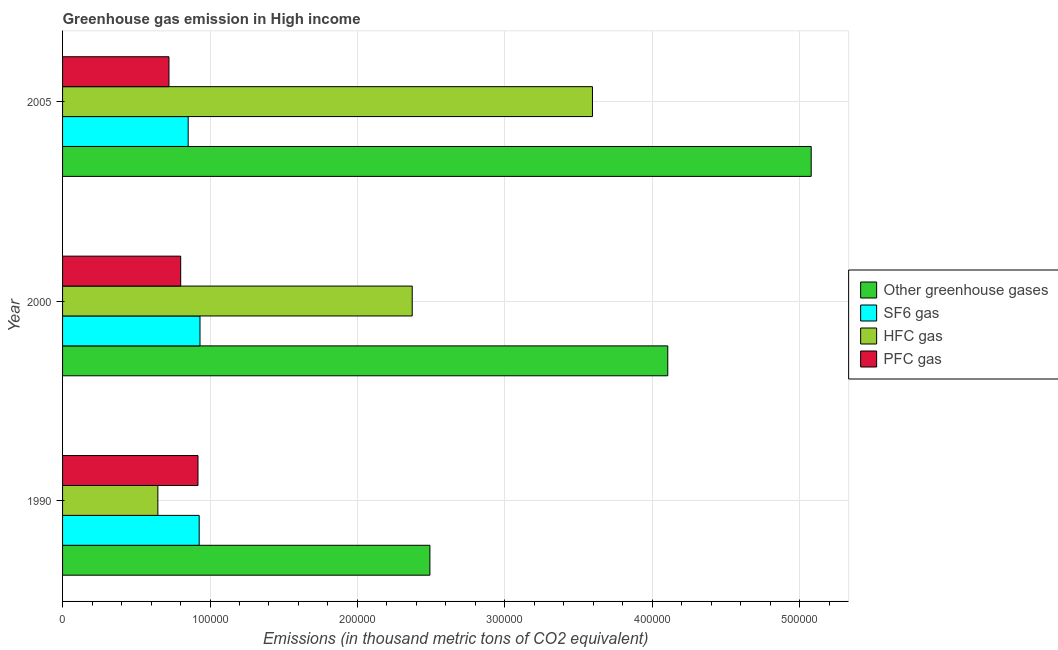How many groups of bars are there?
Keep it short and to the point. 3. How many bars are there on the 2nd tick from the top?
Keep it short and to the point. 4. How many bars are there on the 3rd tick from the bottom?
Provide a succinct answer. 4. What is the label of the 2nd group of bars from the top?
Your response must be concise. 2000. What is the emission of sf6 gas in 2000?
Offer a terse response. 9.32e+04. Across all years, what is the maximum emission of hfc gas?
Provide a short and direct response. 3.59e+05. Across all years, what is the minimum emission of hfc gas?
Give a very brief answer. 6.46e+04. In which year was the emission of hfc gas minimum?
Make the answer very short. 1990. What is the total emission of greenhouse gases in the graph?
Your answer should be very brief. 1.17e+06. What is the difference between the emission of greenhouse gases in 1990 and that in 2005?
Your response must be concise. -2.59e+05. What is the difference between the emission of sf6 gas in 1990 and the emission of greenhouse gases in 2005?
Keep it short and to the point. -4.15e+05. What is the average emission of sf6 gas per year?
Ensure brevity in your answer.  9.04e+04. In the year 1990, what is the difference between the emission of sf6 gas and emission of hfc gas?
Keep it short and to the point. 2.80e+04. What is the ratio of the emission of pfc gas in 1990 to that in 2000?
Your response must be concise. 1.15. Is the difference between the emission of greenhouse gases in 1990 and 2005 greater than the difference between the emission of pfc gas in 1990 and 2005?
Offer a terse response. No. What is the difference between the highest and the second highest emission of pfc gas?
Offer a terse response. 1.17e+04. What is the difference between the highest and the lowest emission of greenhouse gases?
Make the answer very short. 2.59e+05. In how many years, is the emission of pfc gas greater than the average emission of pfc gas taken over all years?
Your answer should be compact. 1. Is the sum of the emission of greenhouse gases in 2000 and 2005 greater than the maximum emission of sf6 gas across all years?
Keep it short and to the point. Yes. Is it the case that in every year, the sum of the emission of sf6 gas and emission of hfc gas is greater than the sum of emission of greenhouse gases and emission of pfc gas?
Keep it short and to the point. No. What does the 2nd bar from the top in 1990 represents?
Give a very brief answer. HFC gas. What does the 2nd bar from the bottom in 2000 represents?
Provide a succinct answer. SF6 gas. How many bars are there?
Offer a very short reply. 12. How many years are there in the graph?
Provide a short and direct response. 3. What is the difference between two consecutive major ticks on the X-axis?
Your answer should be compact. 1.00e+05. Are the values on the major ticks of X-axis written in scientific E-notation?
Ensure brevity in your answer.  No. Does the graph contain any zero values?
Provide a short and direct response. No. What is the title of the graph?
Your response must be concise. Greenhouse gas emission in High income. Does "Secondary general education" appear as one of the legend labels in the graph?
Provide a succinct answer. No. What is the label or title of the X-axis?
Offer a very short reply. Emissions (in thousand metric tons of CO2 equivalent). What is the label or title of the Y-axis?
Provide a short and direct response. Year. What is the Emissions (in thousand metric tons of CO2 equivalent) of Other greenhouse gases in 1990?
Make the answer very short. 2.49e+05. What is the Emissions (in thousand metric tons of CO2 equivalent) of SF6 gas in 1990?
Offer a very short reply. 9.27e+04. What is the Emissions (in thousand metric tons of CO2 equivalent) in HFC gas in 1990?
Your response must be concise. 6.46e+04. What is the Emissions (in thousand metric tons of CO2 equivalent) in PFC gas in 1990?
Keep it short and to the point. 9.19e+04. What is the Emissions (in thousand metric tons of CO2 equivalent) of Other greenhouse gases in 2000?
Provide a short and direct response. 4.10e+05. What is the Emissions (in thousand metric tons of CO2 equivalent) of SF6 gas in 2000?
Offer a terse response. 9.32e+04. What is the Emissions (in thousand metric tons of CO2 equivalent) in HFC gas in 2000?
Make the answer very short. 2.37e+05. What is the Emissions (in thousand metric tons of CO2 equivalent) of PFC gas in 2000?
Ensure brevity in your answer.  8.01e+04. What is the Emissions (in thousand metric tons of CO2 equivalent) of Other greenhouse gases in 2005?
Your response must be concise. 5.08e+05. What is the Emissions (in thousand metric tons of CO2 equivalent) of SF6 gas in 2005?
Offer a very short reply. 8.52e+04. What is the Emissions (in thousand metric tons of CO2 equivalent) of HFC gas in 2005?
Offer a very short reply. 3.59e+05. What is the Emissions (in thousand metric tons of CO2 equivalent) in PFC gas in 2005?
Give a very brief answer. 7.22e+04. Across all years, what is the maximum Emissions (in thousand metric tons of CO2 equivalent) of Other greenhouse gases?
Your answer should be compact. 5.08e+05. Across all years, what is the maximum Emissions (in thousand metric tons of CO2 equivalent) in SF6 gas?
Make the answer very short. 9.32e+04. Across all years, what is the maximum Emissions (in thousand metric tons of CO2 equivalent) in HFC gas?
Offer a very short reply. 3.59e+05. Across all years, what is the maximum Emissions (in thousand metric tons of CO2 equivalent) of PFC gas?
Offer a very short reply. 9.19e+04. Across all years, what is the minimum Emissions (in thousand metric tons of CO2 equivalent) of Other greenhouse gases?
Your answer should be compact. 2.49e+05. Across all years, what is the minimum Emissions (in thousand metric tons of CO2 equivalent) of SF6 gas?
Your answer should be compact. 8.52e+04. Across all years, what is the minimum Emissions (in thousand metric tons of CO2 equivalent) in HFC gas?
Offer a terse response. 6.46e+04. Across all years, what is the minimum Emissions (in thousand metric tons of CO2 equivalent) in PFC gas?
Your answer should be compact. 7.22e+04. What is the total Emissions (in thousand metric tons of CO2 equivalent) in Other greenhouse gases in the graph?
Your answer should be very brief. 1.17e+06. What is the total Emissions (in thousand metric tons of CO2 equivalent) in SF6 gas in the graph?
Provide a short and direct response. 2.71e+05. What is the total Emissions (in thousand metric tons of CO2 equivalent) in HFC gas in the graph?
Provide a short and direct response. 6.61e+05. What is the total Emissions (in thousand metric tons of CO2 equivalent) of PFC gas in the graph?
Your answer should be compact. 2.44e+05. What is the difference between the Emissions (in thousand metric tons of CO2 equivalent) in Other greenhouse gases in 1990 and that in 2000?
Provide a short and direct response. -1.61e+05. What is the difference between the Emissions (in thousand metric tons of CO2 equivalent) in SF6 gas in 1990 and that in 2000?
Keep it short and to the point. -551.2. What is the difference between the Emissions (in thousand metric tons of CO2 equivalent) in HFC gas in 1990 and that in 2000?
Offer a terse response. -1.73e+05. What is the difference between the Emissions (in thousand metric tons of CO2 equivalent) of PFC gas in 1990 and that in 2000?
Offer a terse response. 1.17e+04. What is the difference between the Emissions (in thousand metric tons of CO2 equivalent) of Other greenhouse gases in 1990 and that in 2005?
Provide a short and direct response. -2.59e+05. What is the difference between the Emissions (in thousand metric tons of CO2 equivalent) in SF6 gas in 1990 and that in 2005?
Give a very brief answer. 7470.39. What is the difference between the Emissions (in thousand metric tons of CO2 equivalent) of HFC gas in 1990 and that in 2005?
Your response must be concise. -2.95e+05. What is the difference between the Emissions (in thousand metric tons of CO2 equivalent) in PFC gas in 1990 and that in 2005?
Ensure brevity in your answer.  1.97e+04. What is the difference between the Emissions (in thousand metric tons of CO2 equivalent) of Other greenhouse gases in 2000 and that in 2005?
Your answer should be compact. -9.73e+04. What is the difference between the Emissions (in thousand metric tons of CO2 equivalent) in SF6 gas in 2000 and that in 2005?
Offer a terse response. 8021.59. What is the difference between the Emissions (in thousand metric tons of CO2 equivalent) of HFC gas in 2000 and that in 2005?
Provide a succinct answer. -1.22e+05. What is the difference between the Emissions (in thousand metric tons of CO2 equivalent) of PFC gas in 2000 and that in 2005?
Offer a very short reply. 7954.84. What is the difference between the Emissions (in thousand metric tons of CO2 equivalent) in Other greenhouse gases in 1990 and the Emissions (in thousand metric tons of CO2 equivalent) in SF6 gas in 2000?
Ensure brevity in your answer.  1.56e+05. What is the difference between the Emissions (in thousand metric tons of CO2 equivalent) of Other greenhouse gases in 1990 and the Emissions (in thousand metric tons of CO2 equivalent) of HFC gas in 2000?
Provide a succinct answer. 1.20e+04. What is the difference between the Emissions (in thousand metric tons of CO2 equivalent) of Other greenhouse gases in 1990 and the Emissions (in thousand metric tons of CO2 equivalent) of PFC gas in 2000?
Keep it short and to the point. 1.69e+05. What is the difference between the Emissions (in thousand metric tons of CO2 equivalent) in SF6 gas in 1990 and the Emissions (in thousand metric tons of CO2 equivalent) in HFC gas in 2000?
Offer a terse response. -1.44e+05. What is the difference between the Emissions (in thousand metric tons of CO2 equivalent) in SF6 gas in 1990 and the Emissions (in thousand metric tons of CO2 equivalent) in PFC gas in 2000?
Offer a very short reply. 1.25e+04. What is the difference between the Emissions (in thousand metric tons of CO2 equivalent) of HFC gas in 1990 and the Emissions (in thousand metric tons of CO2 equivalent) of PFC gas in 2000?
Ensure brevity in your answer.  -1.55e+04. What is the difference between the Emissions (in thousand metric tons of CO2 equivalent) of Other greenhouse gases in 1990 and the Emissions (in thousand metric tons of CO2 equivalent) of SF6 gas in 2005?
Offer a terse response. 1.64e+05. What is the difference between the Emissions (in thousand metric tons of CO2 equivalent) of Other greenhouse gases in 1990 and the Emissions (in thousand metric tons of CO2 equivalent) of HFC gas in 2005?
Your response must be concise. -1.10e+05. What is the difference between the Emissions (in thousand metric tons of CO2 equivalent) of Other greenhouse gases in 1990 and the Emissions (in thousand metric tons of CO2 equivalent) of PFC gas in 2005?
Provide a short and direct response. 1.77e+05. What is the difference between the Emissions (in thousand metric tons of CO2 equivalent) of SF6 gas in 1990 and the Emissions (in thousand metric tons of CO2 equivalent) of HFC gas in 2005?
Your response must be concise. -2.67e+05. What is the difference between the Emissions (in thousand metric tons of CO2 equivalent) in SF6 gas in 1990 and the Emissions (in thousand metric tons of CO2 equivalent) in PFC gas in 2005?
Offer a very short reply. 2.05e+04. What is the difference between the Emissions (in thousand metric tons of CO2 equivalent) of HFC gas in 1990 and the Emissions (in thousand metric tons of CO2 equivalent) of PFC gas in 2005?
Provide a succinct answer. -7533.46. What is the difference between the Emissions (in thousand metric tons of CO2 equivalent) of Other greenhouse gases in 2000 and the Emissions (in thousand metric tons of CO2 equivalent) of SF6 gas in 2005?
Make the answer very short. 3.25e+05. What is the difference between the Emissions (in thousand metric tons of CO2 equivalent) in Other greenhouse gases in 2000 and the Emissions (in thousand metric tons of CO2 equivalent) in HFC gas in 2005?
Provide a short and direct response. 5.11e+04. What is the difference between the Emissions (in thousand metric tons of CO2 equivalent) in Other greenhouse gases in 2000 and the Emissions (in thousand metric tons of CO2 equivalent) in PFC gas in 2005?
Ensure brevity in your answer.  3.38e+05. What is the difference between the Emissions (in thousand metric tons of CO2 equivalent) of SF6 gas in 2000 and the Emissions (in thousand metric tons of CO2 equivalent) of HFC gas in 2005?
Ensure brevity in your answer.  -2.66e+05. What is the difference between the Emissions (in thousand metric tons of CO2 equivalent) of SF6 gas in 2000 and the Emissions (in thousand metric tons of CO2 equivalent) of PFC gas in 2005?
Offer a terse response. 2.10e+04. What is the difference between the Emissions (in thousand metric tons of CO2 equivalent) of HFC gas in 2000 and the Emissions (in thousand metric tons of CO2 equivalent) of PFC gas in 2005?
Your answer should be compact. 1.65e+05. What is the average Emissions (in thousand metric tons of CO2 equivalent) of Other greenhouse gases per year?
Make the answer very short. 3.89e+05. What is the average Emissions (in thousand metric tons of CO2 equivalent) in SF6 gas per year?
Provide a short and direct response. 9.04e+04. What is the average Emissions (in thousand metric tons of CO2 equivalent) of HFC gas per year?
Provide a short and direct response. 2.20e+05. What is the average Emissions (in thousand metric tons of CO2 equivalent) of PFC gas per year?
Give a very brief answer. 8.14e+04. In the year 1990, what is the difference between the Emissions (in thousand metric tons of CO2 equivalent) of Other greenhouse gases and Emissions (in thousand metric tons of CO2 equivalent) of SF6 gas?
Your response must be concise. 1.56e+05. In the year 1990, what is the difference between the Emissions (in thousand metric tons of CO2 equivalent) of Other greenhouse gases and Emissions (in thousand metric tons of CO2 equivalent) of HFC gas?
Provide a short and direct response. 1.85e+05. In the year 1990, what is the difference between the Emissions (in thousand metric tons of CO2 equivalent) in Other greenhouse gases and Emissions (in thousand metric tons of CO2 equivalent) in PFC gas?
Make the answer very short. 1.57e+05. In the year 1990, what is the difference between the Emissions (in thousand metric tons of CO2 equivalent) of SF6 gas and Emissions (in thousand metric tons of CO2 equivalent) of HFC gas?
Offer a terse response. 2.80e+04. In the year 1990, what is the difference between the Emissions (in thousand metric tons of CO2 equivalent) in SF6 gas and Emissions (in thousand metric tons of CO2 equivalent) in PFC gas?
Your answer should be compact. 810.4. In the year 1990, what is the difference between the Emissions (in thousand metric tons of CO2 equivalent) of HFC gas and Emissions (in thousand metric tons of CO2 equivalent) of PFC gas?
Offer a terse response. -2.72e+04. In the year 2000, what is the difference between the Emissions (in thousand metric tons of CO2 equivalent) of Other greenhouse gases and Emissions (in thousand metric tons of CO2 equivalent) of SF6 gas?
Provide a short and direct response. 3.17e+05. In the year 2000, what is the difference between the Emissions (in thousand metric tons of CO2 equivalent) of Other greenhouse gases and Emissions (in thousand metric tons of CO2 equivalent) of HFC gas?
Provide a succinct answer. 1.73e+05. In the year 2000, what is the difference between the Emissions (in thousand metric tons of CO2 equivalent) in Other greenhouse gases and Emissions (in thousand metric tons of CO2 equivalent) in PFC gas?
Give a very brief answer. 3.30e+05. In the year 2000, what is the difference between the Emissions (in thousand metric tons of CO2 equivalent) in SF6 gas and Emissions (in thousand metric tons of CO2 equivalent) in HFC gas?
Offer a very short reply. -1.44e+05. In the year 2000, what is the difference between the Emissions (in thousand metric tons of CO2 equivalent) of SF6 gas and Emissions (in thousand metric tons of CO2 equivalent) of PFC gas?
Keep it short and to the point. 1.31e+04. In the year 2000, what is the difference between the Emissions (in thousand metric tons of CO2 equivalent) of HFC gas and Emissions (in thousand metric tons of CO2 equivalent) of PFC gas?
Keep it short and to the point. 1.57e+05. In the year 2005, what is the difference between the Emissions (in thousand metric tons of CO2 equivalent) of Other greenhouse gases and Emissions (in thousand metric tons of CO2 equivalent) of SF6 gas?
Your response must be concise. 4.23e+05. In the year 2005, what is the difference between the Emissions (in thousand metric tons of CO2 equivalent) in Other greenhouse gases and Emissions (in thousand metric tons of CO2 equivalent) in HFC gas?
Your answer should be very brief. 1.48e+05. In the year 2005, what is the difference between the Emissions (in thousand metric tons of CO2 equivalent) of Other greenhouse gases and Emissions (in thousand metric tons of CO2 equivalent) of PFC gas?
Your answer should be very brief. 4.36e+05. In the year 2005, what is the difference between the Emissions (in thousand metric tons of CO2 equivalent) in SF6 gas and Emissions (in thousand metric tons of CO2 equivalent) in HFC gas?
Your answer should be compact. -2.74e+05. In the year 2005, what is the difference between the Emissions (in thousand metric tons of CO2 equivalent) in SF6 gas and Emissions (in thousand metric tons of CO2 equivalent) in PFC gas?
Offer a very short reply. 1.30e+04. In the year 2005, what is the difference between the Emissions (in thousand metric tons of CO2 equivalent) in HFC gas and Emissions (in thousand metric tons of CO2 equivalent) in PFC gas?
Your answer should be very brief. 2.87e+05. What is the ratio of the Emissions (in thousand metric tons of CO2 equivalent) of Other greenhouse gases in 1990 to that in 2000?
Your answer should be very brief. 0.61. What is the ratio of the Emissions (in thousand metric tons of CO2 equivalent) of HFC gas in 1990 to that in 2000?
Your answer should be compact. 0.27. What is the ratio of the Emissions (in thousand metric tons of CO2 equivalent) of PFC gas in 1990 to that in 2000?
Keep it short and to the point. 1.15. What is the ratio of the Emissions (in thousand metric tons of CO2 equivalent) in Other greenhouse gases in 1990 to that in 2005?
Make the answer very short. 0.49. What is the ratio of the Emissions (in thousand metric tons of CO2 equivalent) of SF6 gas in 1990 to that in 2005?
Your response must be concise. 1.09. What is the ratio of the Emissions (in thousand metric tons of CO2 equivalent) in HFC gas in 1990 to that in 2005?
Your answer should be very brief. 0.18. What is the ratio of the Emissions (in thousand metric tons of CO2 equivalent) of PFC gas in 1990 to that in 2005?
Your response must be concise. 1.27. What is the ratio of the Emissions (in thousand metric tons of CO2 equivalent) in Other greenhouse gases in 2000 to that in 2005?
Offer a terse response. 0.81. What is the ratio of the Emissions (in thousand metric tons of CO2 equivalent) of SF6 gas in 2000 to that in 2005?
Provide a short and direct response. 1.09. What is the ratio of the Emissions (in thousand metric tons of CO2 equivalent) of HFC gas in 2000 to that in 2005?
Make the answer very short. 0.66. What is the ratio of the Emissions (in thousand metric tons of CO2 equivalent) in PFC gas in 2000 to that in 2005?
Your response must be concise. 1.11. What is the difference between the highest and the second highest Emissions (in thousand metric tons of CO2 equivalent) of Other greenhouse gases?
Offer a very short reply. 9.73e+04. What is the difference between the highest and the second highest Emissions (in thousand metric tons of CO2 equivalent) in SF6 gas?
Provide a succinct answer. 551.2. What is the difference between the highest and the second highest Emissions (in thousand metric tons of CO2 equivalent) of HFC gas?
Your answer should be very brief. 1.22e+05. What is the difference between the highest and the second highest Emissions (in thousand metric tons of CO2 equivalent) in PFC gas?
Make the answer very short. 1.17e+04. What is the difference between the highest and the lowest Emissions (in thousand metric tons of CO2 equivalent) of Other greenhouse gases?
Your answer should be very brief. 2.59e+05. What is the difference between the highest and the lowest Emissions (in thousand metric tons of CO2 equivalent) in SF6 gas?
Your answer should be compact. 8021.59. What is the difference between the highest and the lowest Emissions (in thousand metric tons of CO2 equivalent) in HFC gas?
Ensure brevity in your answer.  2.95e+05. What is the difference between the highest and the lowest Emissions (in thousand metric tons of CO2 equivalent) in PFC gas?
Your answer should be very brief. 1.97e+04. 